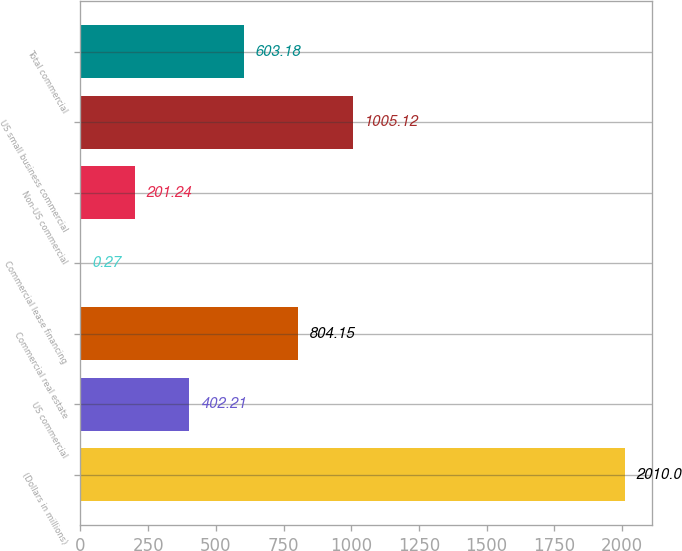Convert chart. <chart><loc_0><loc_0><loc_500><loc_500><bar_chart><fcel>(Dollars in millions)<fcel>US commercial<fcel>Commercial real estate<fcel>Commercial lease financing<fcel>Non-US commercial<fcel>US small business commercial<fcel>Total commercial<nl><fcel>2010<fcel>402.21<fcel>804.15<fcel>0.27<fcel>201.24<fcel>1005.12<fcel>603.18<nl></chart> 